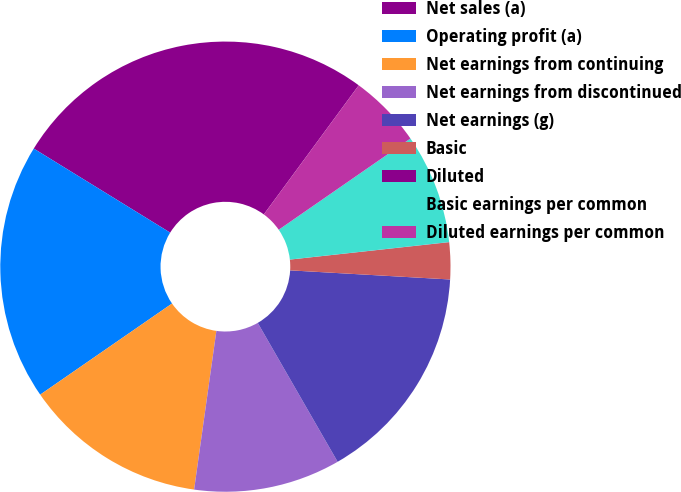<chart> <loc_0><loc_0><loc_500><loc_500><pie_chart><fcel>Net sales (a)<fcel>Operating profit (a)<fcel>Net earnings from continuing<fcel>Net earnings from discontinued<fcel>Net earnings (g)<fcel>Basic<fcel>Diluted<fcel>Basic earnings per common<fcel>Diluted earnings per common<nl><fcel>26.31%<fcel>18.42%<fcel>13.16%<fcel>10.53%<fcel>15.79%<fcel>2.64%<fcel>0.01%<fcel>7.9%<fcel>5.27%<nl></chart> 